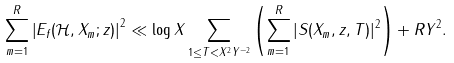Convert formula to latex. <formula><loc_0><loc_0><loc_500><loc_500>\sum _ { m = 1 } ^ { R } \left | E _ { f } ( \mathcal { H } , X _ { m } ; z ) \right | ^ { 2 } \ll \log X \sum _ { 1 \leq T < X ^ { 2 } Y ^ { - 2 } } \left ( \sum _ { m = 1 } ^ { R } | S ( X _ { m } , z , T ) | ^ { 2 } \right ) + R Y ^ { 2 } .</formula> 